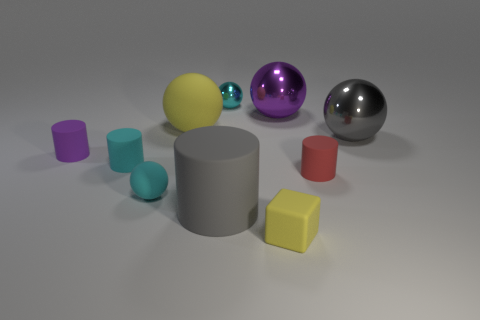Does the large rubber cylinder have the same color as the tiny metallic ball?
Ensure brevity in your answer.  No. Are there any yellow objects of the same shape as the cyan metallic thing?
Offer a very short reply. Yes. There is a purple ball that is behind the gray cylinder; is its size the same as the gray rubber cylinder?
Provide a short and direct response. Yes. Are there any big purple rubber balls?
Offer a terse response. No. How many things are either rubber things that are behind the small cyan matte sphere or large blue rubber cubes?
Your answer should be very brief. 4. There is a small rubber cube; does it have the same color as the rubber cylinder to the right of the small metal ball?
Give a very brief answer. No. Are there any yellow things that have the same size as the gray cylinder?
Your answer should be very brief. Yes. What material is the gray object that is in front of the cylinder on the right side of the big gray cylinder made of?
Your answer should be very brief. Rubber. What number of big cylinders are the same color as the small metal ball?
Provide a succinct answer. 0. The small purple object that is the same material as the yellow cube is what shape?
Provide a succinct answer. Cylinder. 